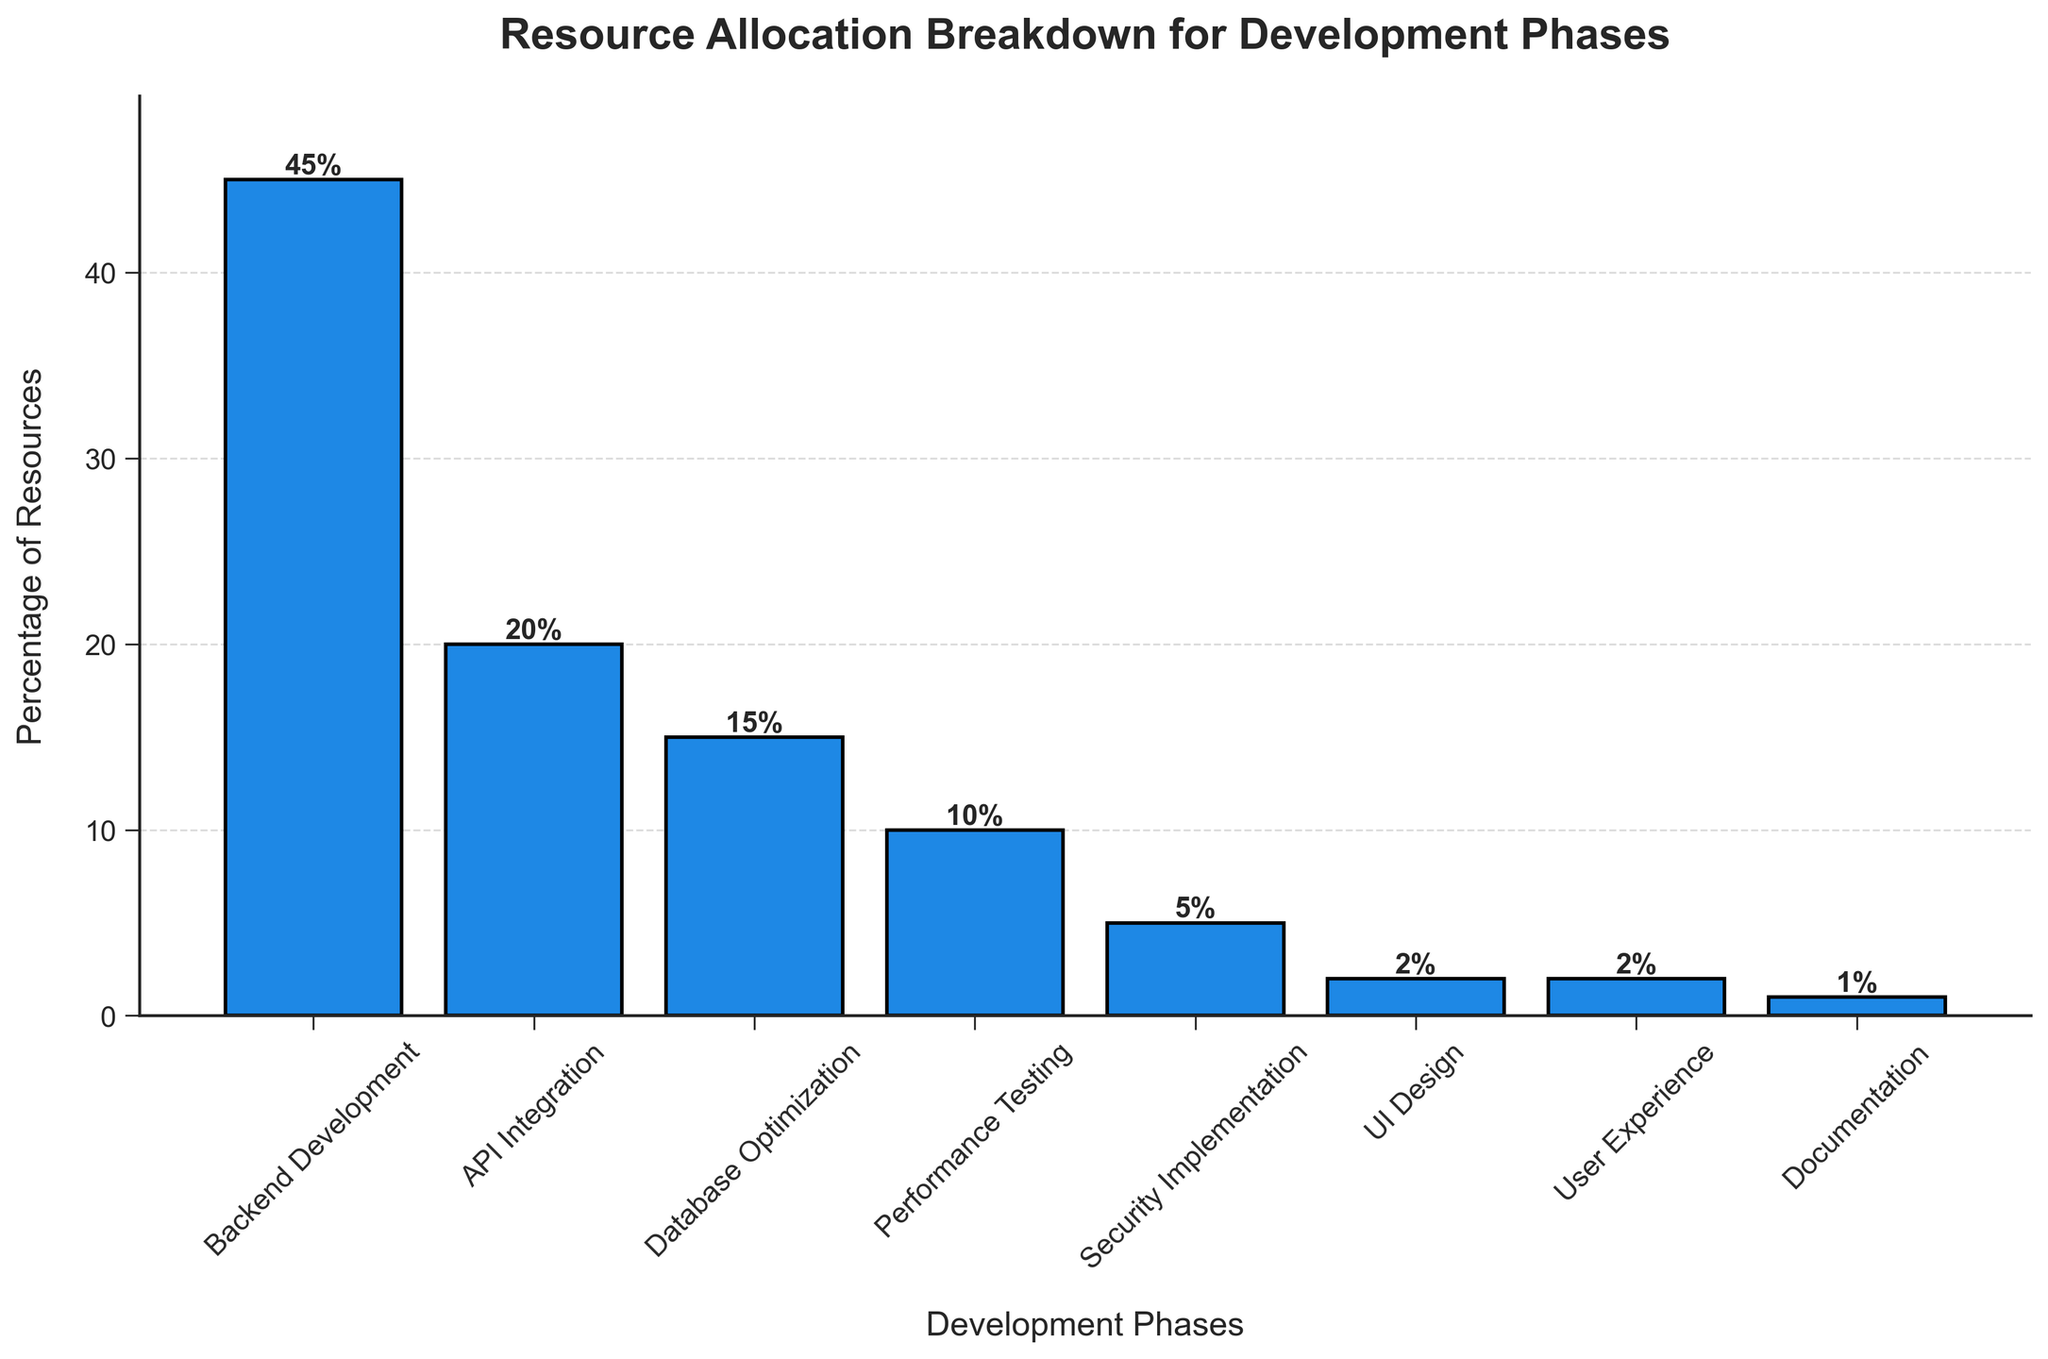Which phase receives the most resource allocation? The figure shows that Backend Development has the highest bar, indicating it receives the most resource allocation.
Answer: Backend Development Which phase has the least resource allocation? The figure shows that Documentation has the shortest bar, indicating it receives the least resource allocation.
Answer: Documentation Is the resource allocation for API Integration greater than for Performance Testing? The bar for API Integration (20%) is higher than the bar for Performance Testing (10%), indicating API Integration receives more resources.
Answer: Yes How much higher is the percentage of resource allocation for Backend Development compared to Security Implementation? The percentage for Backend Development is 45% and for Security Implementation is 5%. The difference is 45% - 5% = 40%.
Answer: 40% What is the total percentage of resources allocated to UI Design and User Experience? UI Design is allocated 2% and User Experience is allocated 2%. Adding them up: 2% + 2% = 4%.
Answer: 4% Do Database Optimization and Performance Testing combined have more resources than Backend Development? Database Optimization has 15% and Performance Testing has 10%, summing to 15% + 10% = 25%, which is less than the 45% allocated to Backend Development.
Answer: No How many phases have less than 10% resource allocation? The figure shows that Security Implementation (5%), UI Design (2%), User Experience (2%), and Documentation (1%) have less than 10%. This totals four phases.
Answer: 4 Is the percentage of resources allocated to API Integration closer to Backend Development or to Database Optimization? Backend Development is 45%, API Integration is 20%, and Database Optimization is 15%. The difference with Backend Development is 45% - 20% = 25%, and with Database Optimization is 20% - 15% = 5%. Thus, it's closer to Database Optimization.
Answer: Database Optimization What is the combined percentage of resources allocated to phases involving testing and security? Performance Testing has 10% and Security Implementation has 5%. Adding them up: 10% + 5% = 15%.
Answer: 15% Among the phases with more than 10% allocation, how many phases are there? Backend Development (45%), API Integration (20%), and Database Optimization (15%) are each more than 10%, summing to three phases.
Answer: 3 